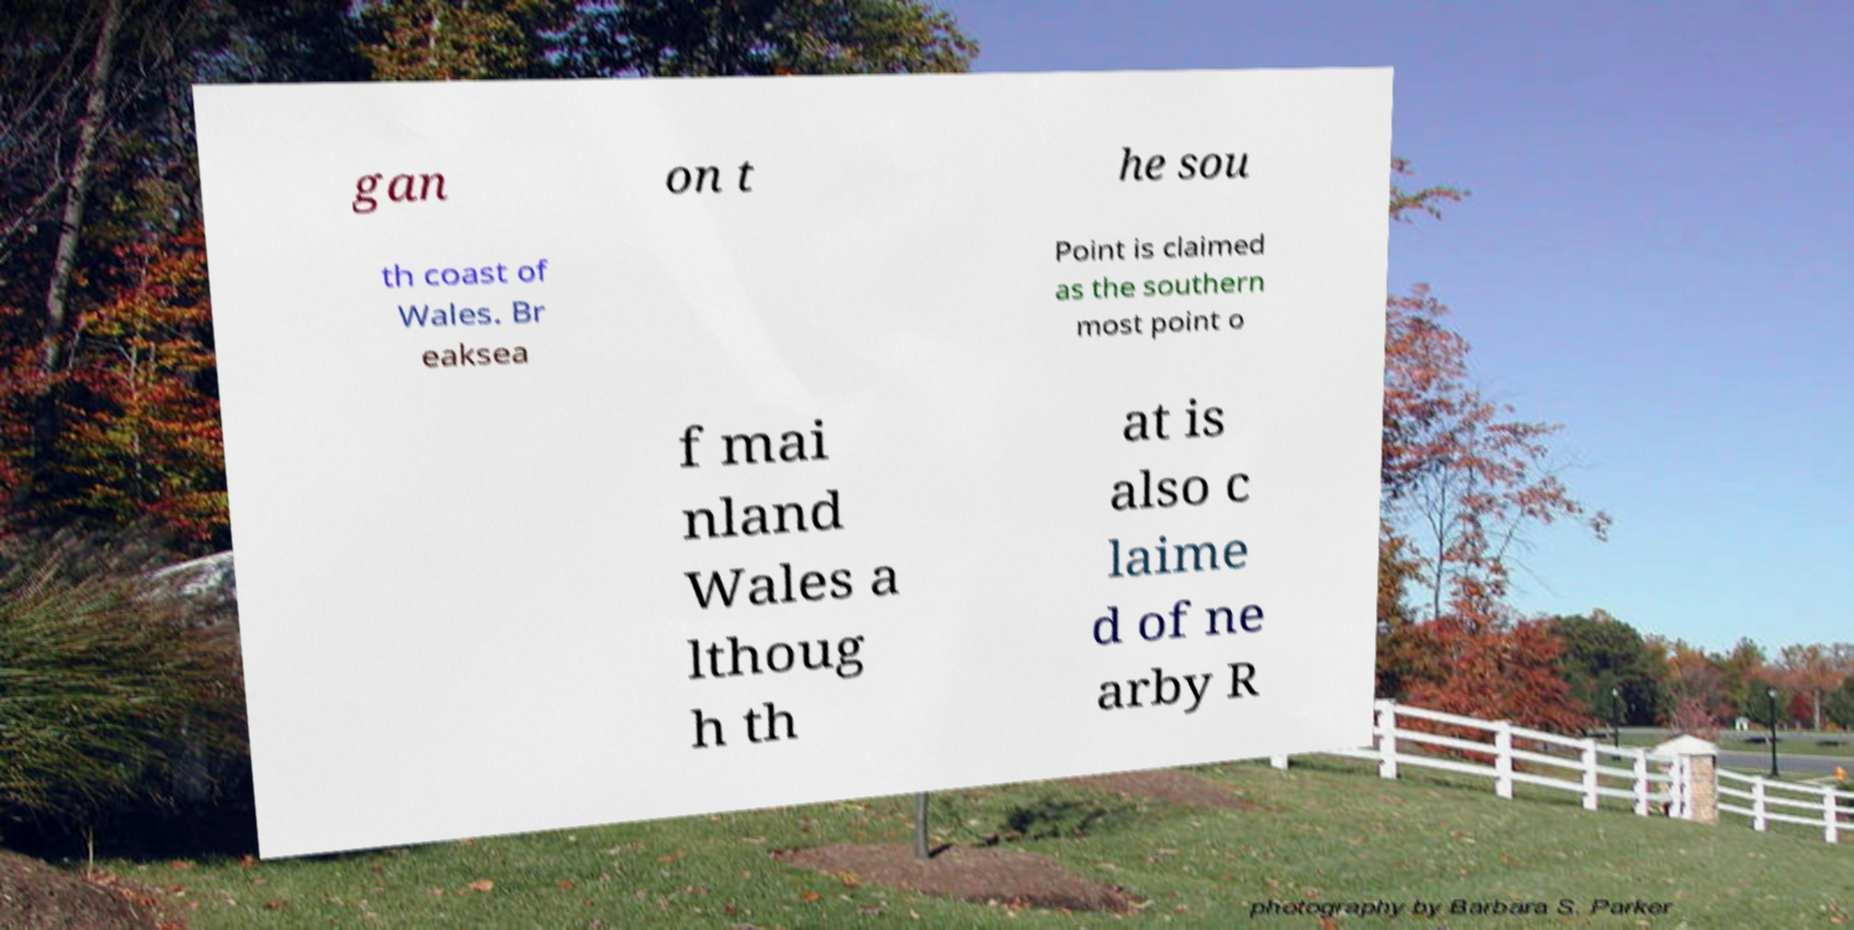I need the written content from this picture converted into text. Can you do that? gan on t he sou th coast of Wales. Br eaksea Point is claimed as the southern most point o f mai nland Wales a lthoug h th at is also c laime d of ne arby R 